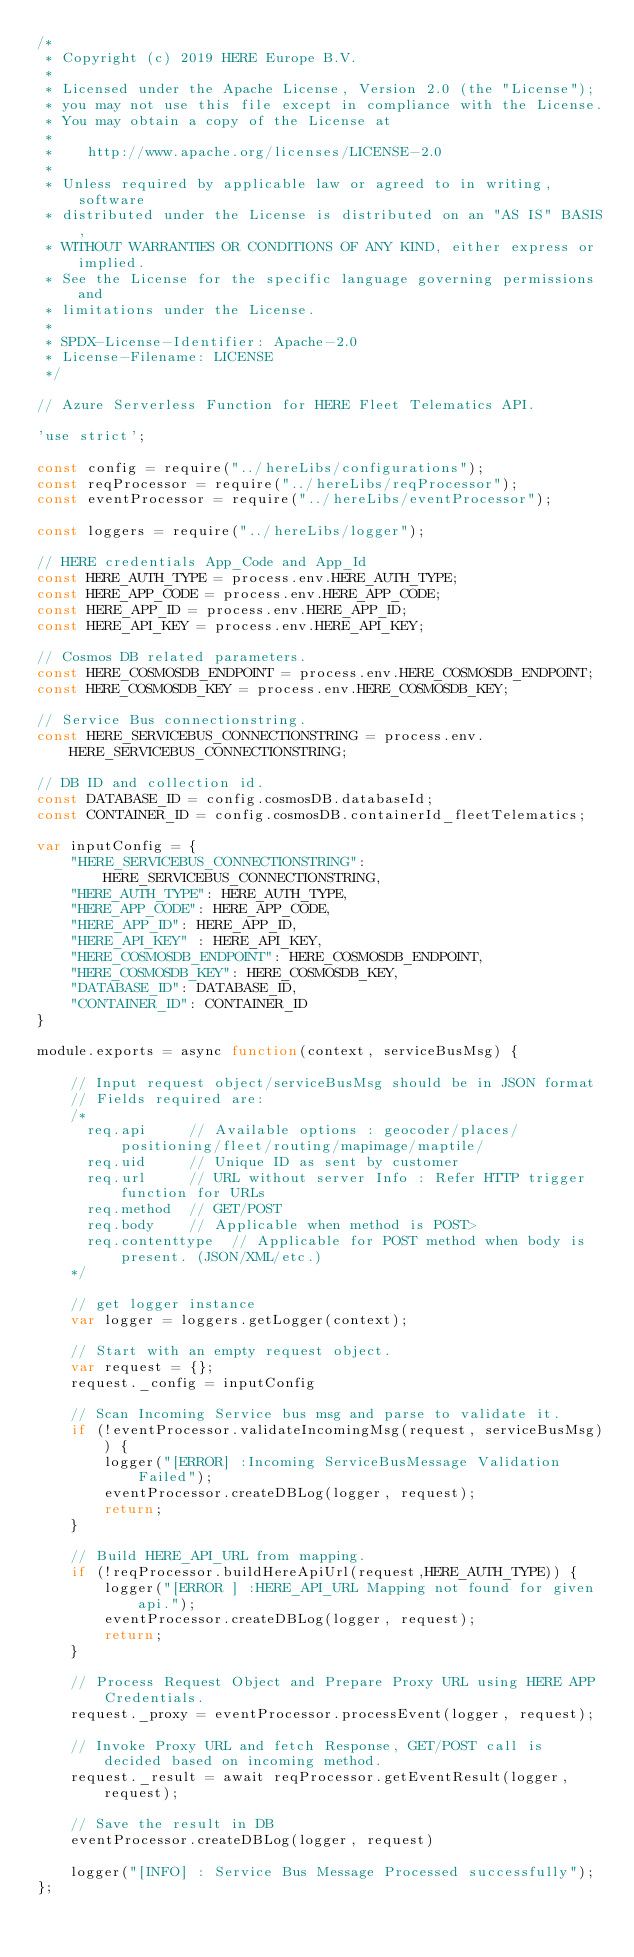<code> <loc_0><loc_0><loc_500><loc_500><_JavaScript_>/*
 * Copyright (c) 2019 HERE Europe B.V.
 *
 * Licensed under the Apache License, Version 2.0 (the "License");
 * you may not use this file except in compliance with the License.
 * You may obtain a copy of the License at
 *
 *    http://www.apache.org/licenses/LICENSE-2.0
 *
 * Unless required by applicable law or agreed to in writing, software
 * distributed under the License is distributed on an "AS IS" BASIS,
 * WITHOUT WARRANTIES OR CONDITIONS OF ANY KIND, either express or implied.
 * See the License for the specific language governing permissions and
 * limitations under the License.
 *
 * SPDX-License-Identifier: Apache-2.0
 * License-Filename: LICENSE
 */

// Azure Serverless Function for HERE Fleet Telematics API.

'use strict';

const config = require("../hereLibs/configurations");
const reqProcessor = require("../hereLibs/reqProcessor");
const eventProcessor = require("../hereLibs/eventProcessor");

const loggers = require("../hereLibs/logger");

// HERE credentials App_Code and App_Id
const HERE_AUTH_TYPE = process.env.HERE_AUTH_TYPE;
const HERE_APP_CODE = process.env.HERE_APP_CODE;
const HERE_APP_ID = process.env.HERE_APP_ID;
const HERE_API_KEY = process.env.HERE_API_KEY;

// Cosmos DB related parameters.
const HERE_COSMOSDB_ENDPOINT = process.env.HERE_COSMOSDB_ENDPOINT;
const HERE_COSMOSDB_KEY = process.env.HERE_COSMOSDB_KEY;

// Service Bus connectionstring. 
const HERE_SERVICEBUS_CONNECTIONSTRING = process.env.HERE_SERVICEBUS_CONNECTIONSTRING;

// DB ID and collection id.
const DATABASE_ID = config.cosmosDB.databaseId;
const CONTAINER_ID = config.cosmosDB.containerId_fleetTelematics;

var inputConfig = {
    "HERE_SERVICEBUS_CONNECTIONSTRING": HERE_SERVICEBUS_CONNECTIONSTRING,
    "HERE_AUTH_TYPE": HERE_AUTH_TYPE,
    "HERE_APP_CODE": HERE_APP_CODE,
    "HERE_APP_ID": HERE_APP_ID,
    "HERE_API_KEY" : HERE_API_KEY,
    "HERE_COSMOSDB_ENDPOINT": HERE_COSMOSDB_ENDPOINT,
    "HERE_COSMOSDB_KEY": HERE_COSMOSDB_KEY,
    "DATABASE_ID": DATABASE_ID,
    "CONTAINER_ID": CONTAINER_ID
}

module.exports = async function(context, serviceBusMsg) {

    // Input request object/serviceBusMsg should be in JSON format
    // Fields required are:
    /*
      req.api     // Available options : geocoder/places/positioning/fleet/routing/mapimage/maptile/
      req.uid     // Unique ID as sent by customer
      req.url     // URL without server Info : Refer HTTP trigger function for URLs
      req.method  // GET/POST 
      req.body    // Applicable when method is POST>
      req.contenttype  // Applicable for POST method when body is present. (JSON/XML/etc.)
    */

    // get logger instance
    var logger = loggers.getLogger(context);

    // Start with an empty request object.
    var request = {};
    request._config = inputConfig

    // Scan Incoming Service bus msg and parse to validate it.
    if (!eventProcessor.validateIncomingMsg(request, serviceBusMsg)) {
        logger("[ERROR] :Incoming ServiceBusMessage Validation Failed");
        eventProcessor.createDBLog(logger, request);
        return;
    }

    // Build HERE_API_URL from mapping.
    if (!reqProcessor.buildHereApiUrl(request,HERE_AUTH_TYPE)) {
        logger("[ERROR ] :HERE_API_URL Mapping not found for given api.");
        eventProcessor.createDBLog(logger, request);
        return;
    }

    // Process Request Object and Prepare Proxy URL using HERE APP Credentials. 
    request._proxy = eventProcessor.processEvent(logger, request);

    // Invoke Proxy URL and fetch Response, GET/POST call is decided based on incoming method.
    request._result = await reqProcessor.getEventResult(logger, request);

    // Save the result in DB
    eventProcessor.createDBLog(logger, request)

    logger("[INFO] : Service Bus Message Processed successfully");
};
</code> 